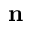<formula> <loc_0><loc_0><loc_500><loc_500>n</formula> 